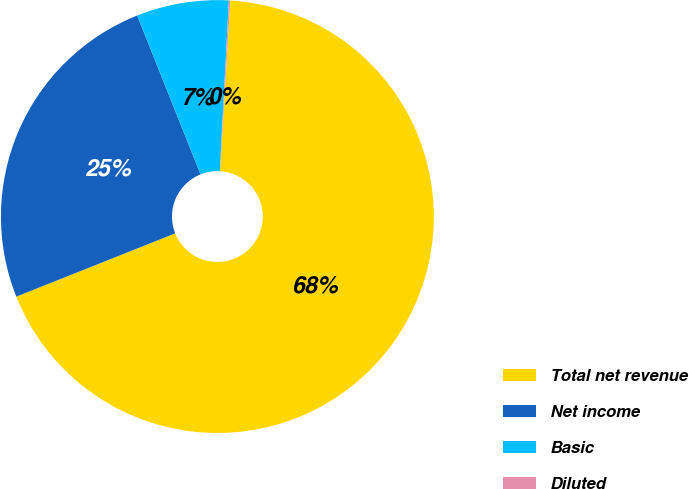<chart> <loc_0><loc_0><loc_500><loc_500><pie_chart><fcel>Total net revenue<fcel>Net income<fcel>Basic<fcel>Diluted<nl><fcel>68.02%<fcel>24.99%<fcel>6.89%<fcel>0.1%<nl></chart> 